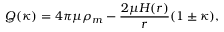Convert formula to latex. <formula><loc_0><loc_0><loc_500><loc_500>Q ( \kappa ) = 4 \pi \mu \rho _ { m } - \frac { 2 \mu H ( r ) } { r } ( 1 \pm \kappa ) ,</formula> 